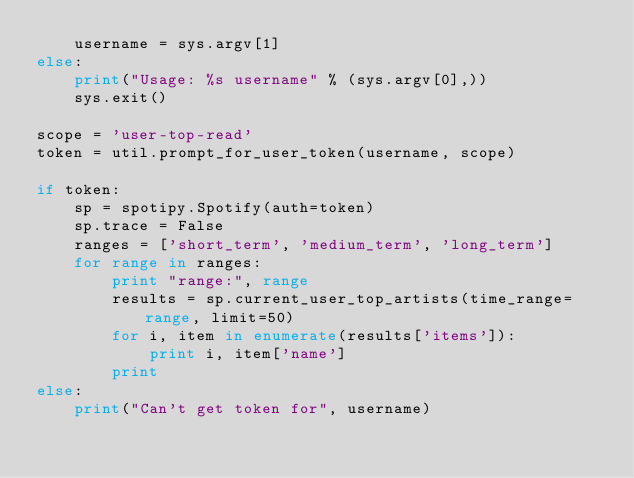Convert code to text. <code><loc_0><loc_0><loc_500><loc_500><_Python_>    username = sys.argv[1]
else:
    print("Usage: %s username" % (sys.argv[0],))
    sys.exit()

scope = 'user-top-read'
token = util.prompt_for_user_token(username, scope)

if token:
    sp = spotipy.Spotify(auth=token)
    sp.trace = False
    ranges = ['short_term', 'medium_term', 'long_term']
    for range in ranges:
        print "range:", range
        results = sp.current_user_top_artists(time_range=range, limit=50)
        for i, item in enumerate(results['items']):
            print i, item['name']
        print
else:
    print("Can't get token for", username)
</code> 